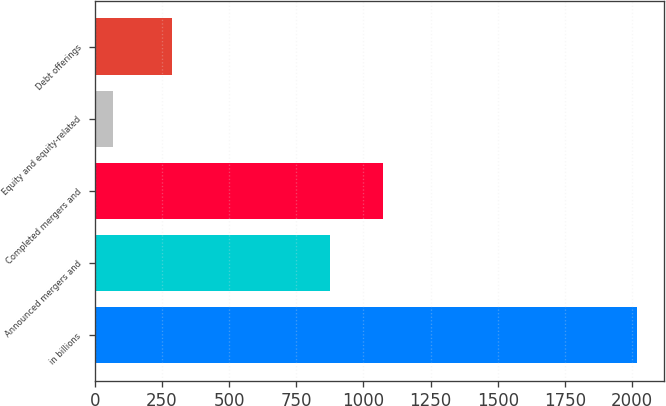Convert chart to OTSL. <chart><loc_0><loc_0><loc_500><loc_500><bar_chart><fcel>in billions<fcel>Announced mergers and<fcel>Completed mergers and<fcel>Equity and equity-related<fcel>Debt offerings<nl><fcel>2017<fcel>877<fcel>1071.8<fcel>69<fcel>289<nl></chart> 